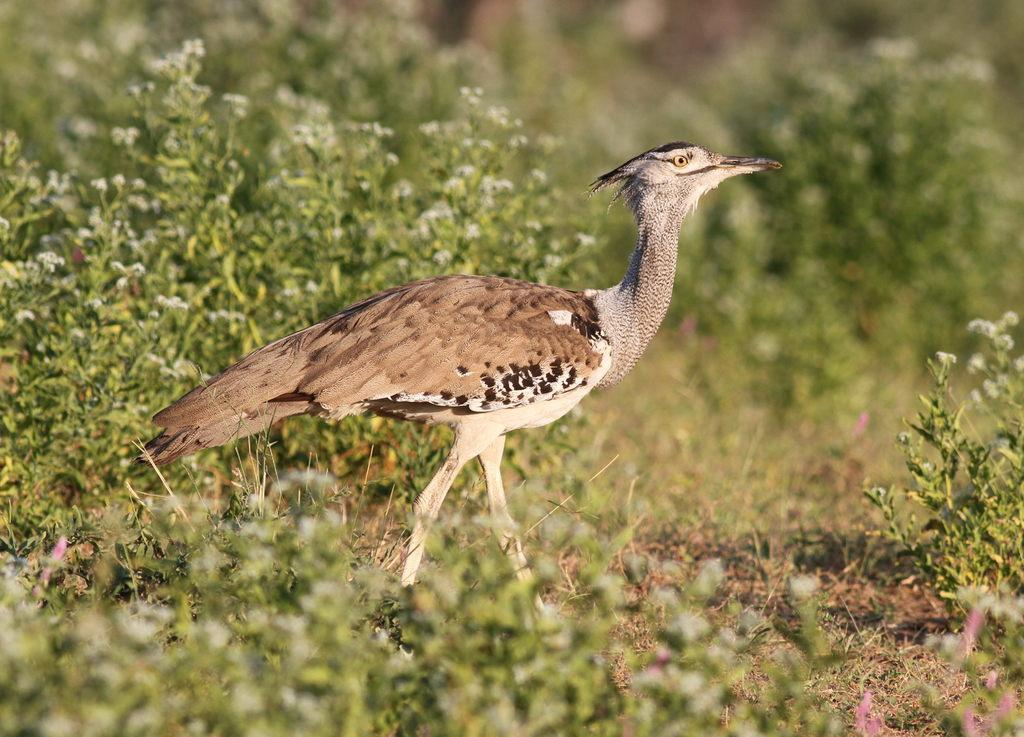What type of animal can be seen in the image? There is a bird in the image. Can you describe the colors of the bird? The bird has brown, black, and ash colors. Where is the bird located in the image? The bird is on the ground. What type of vegetation is visible in the image? There is grass visible in the image. How would you describe the background of the image? The background of the image is blurred. Can you see the bird's friend sitting on the sofa in the image? There is no friend or sofa present in the image; it only features a bird on the ground with grass and a blurred background. 